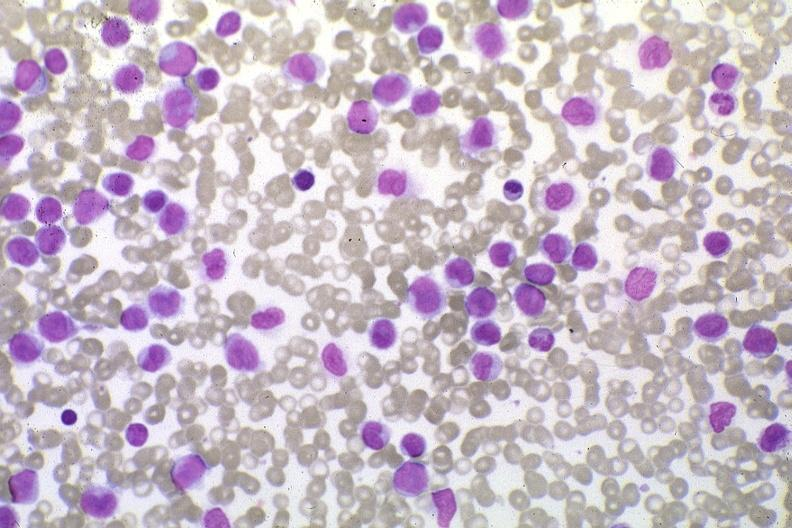what is present?
Answer the question using a single word or phrase. Hematologic 